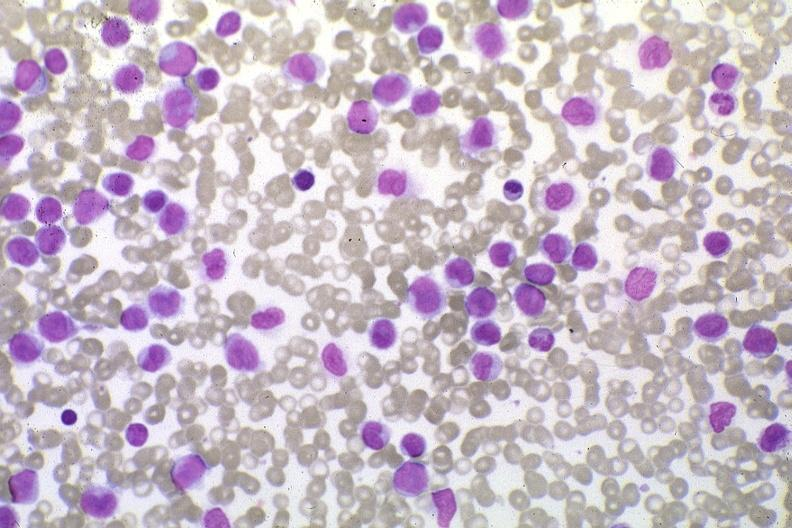what is present?
Answer the question using a single word or phrase. Hematologic 